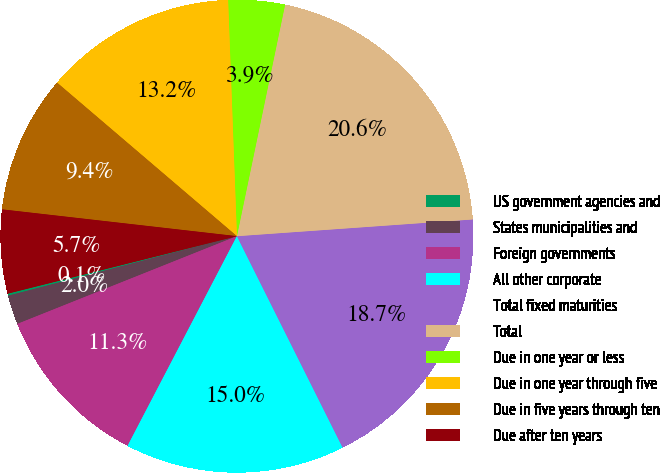<chart> <loc_0><loc_0><loc_500><loc_500><pie_chart><fcel>US government agencies and<fcel>States municipalities and<fcel>Foreign governments<fcel>All other corporate<fcel>Total fixed maturities<fcel>Total<fcel>Due in one year or less<fcel>Due in one year through five<fcel>Due in five years through ten<fcel>Due after ten years<nl><fcel>0.14%<fcel>2.0%<fcel>11.3%<fcel>15.03%<fcel>18.75%<fcel>20.61%<fcel>3.86%<fcel>13.16%<fcel>9.44%<fcel>5.72%<nl></chart> 